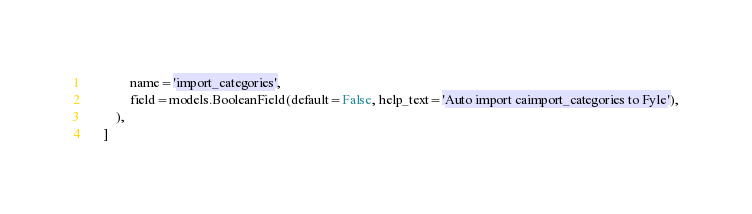<code> <loc_0><loc_0><loc_500><loc_500><_Python_>            name='import_categories',
            field=models.BooleanField(default=False, help_text='Auto import caimport_categories to Fyle'),
        ),
    ]
</code> 